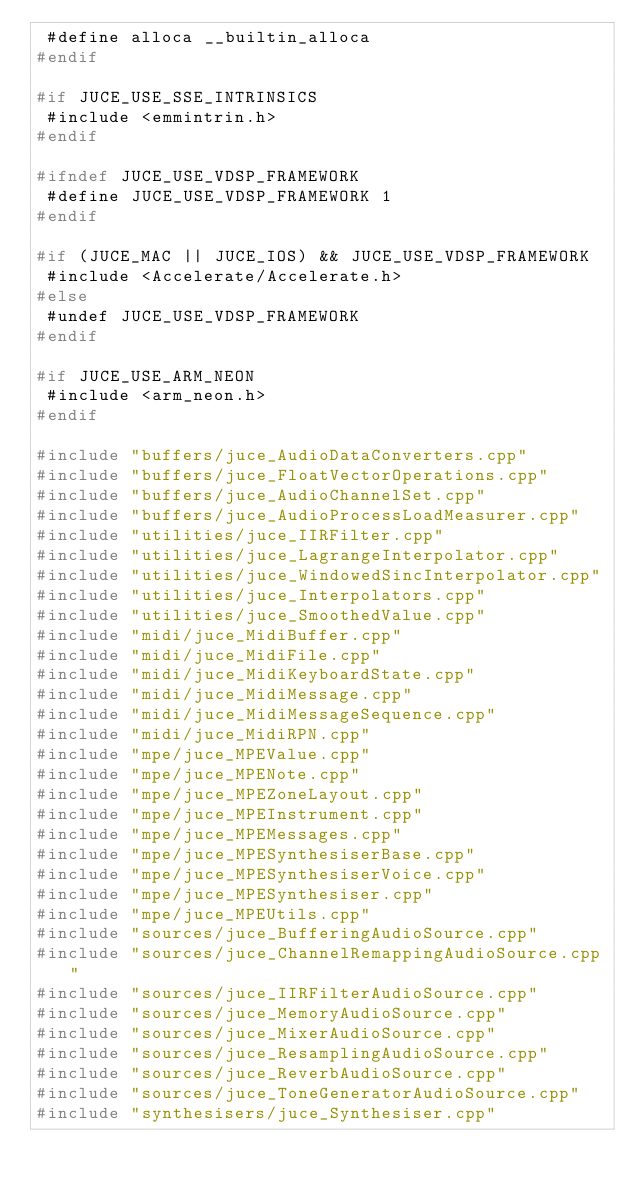<code> <loc_0><loc_0><loc_500><loc_500><_C++_> #define alloca __builtin_alloca
#endif

#if JUCE_USE_SSE_INTRINSICS
 #include <emmintrin.h>
#endif

#ifndef JUCE_USE_VDSP_FRAMEWORK
 #define JUCE_USE_VDSP_FRAMEWORK 1
#endif

#if (JUCE_MAC || JUCE_IOS) && JUCE_USE_VDSP_FRAMEWORK
 #include <Accelerate/Accelerate.h>
#else
 #undef JUCE_USE_VDSP_FRAMEWORK
#endif

#if JUCE_USE_ARM_NEON
 #include <arm_neon.h>
#endif

#include "buffers/juce_AudioDataConverters.cpp"
#include "buffers/juce_FloatVectorOperations.cpp"
#include "buffers/juce_AudioChannelSet.cpp"
#include "buffers/juce_AudioProcessLoadMeasurer.cpp"
#include "utilities/juce_IIRFilter.cpp"
#include "utilities/juce_LagrangeInterpolator.cpp"
#include "utilities/juce_WindowedSincInterpolator.cpp"
#include "utilities/juce_Interpolators.cpp"
#include "utilities/juce_SmoothedValue.cpp"
#include "midi/juce_MidiBuffer.cpp"
#include "midi/juce_MidiFile.cpp"
#include "midi/juce_MidiKeyboardState.cpp"
#include "midi/juce_MidiMessage.cpp"
#include "midi/juce_MidiMessageSequence.cpp"
#include "midi/juce_MidiRPN.cpp"
#include "mpe/juce_MPEValue.cpp"
#include "mpe/juce_MPENote.cpp"
#include "mpe/juce_MPEZoneLayout.cpp"
#include "mpe/juce_MPEInstrument.cpp"
#include "mpe/juce_MPEMessages.cpp"
#include "mpe/juce_MPESynthesiserBase.cpp"
#include "mpe/juce_MPESynthesiserVoice.cpp"
#include "mpe/juce_MPESynthesiser.cpp"
#include "mpe/juce_MPEUtils.cpp"
#include "sources/juce_BufferingAudioSource.cpp"
#include "sources/juce_ChannelRemappingAudioSource.cpp"
#include "sources/juce_IIRFilterAudioSource.cpp"
#include "sources/juce_MemoryAudioSource.cpp"
#include "sources/juce_MixerAudioSource.cpp"
#include "sources/juce_ResamplingAudioSource.cpp"
#include "sources/juce_ReverbAudioSource.cpp"
#include "sources/juce_ToneGeneratorAudioSource.cpp"
#include "synthesisers/juce_Synthesiser.cpp"
</code> 